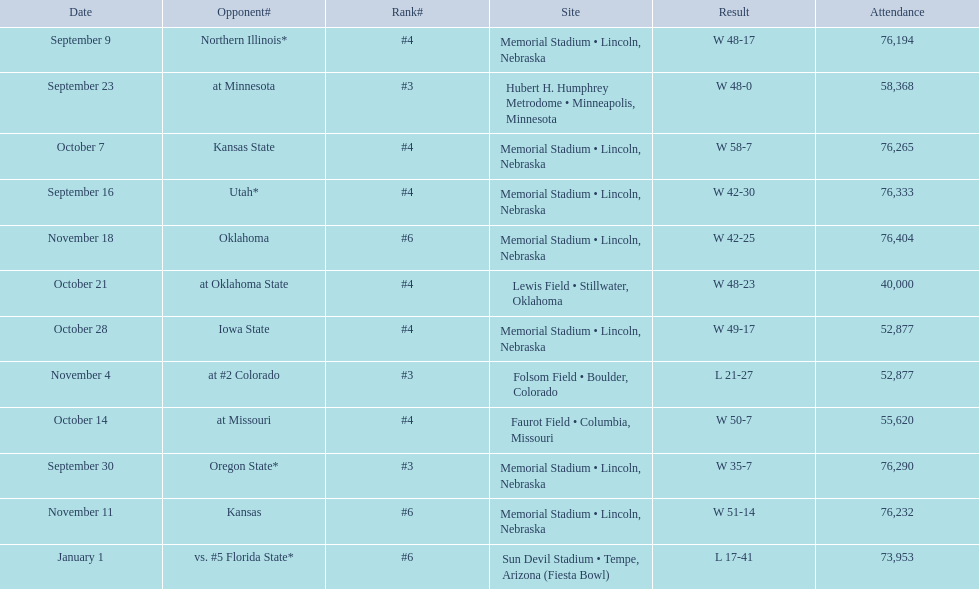Which opponenets did the nebraska cornhuskers score fewer than 40 points against? Oregon State*, at #2 Colorado, vs. #5 Florida State*. Of these games, which ones had an attendance of greater than 70,000? Oregon State*, vs. #5 Florida State*. Which of these opponents did they beat? Oregon State*. How many people were in attendance at that game? 76,290. 